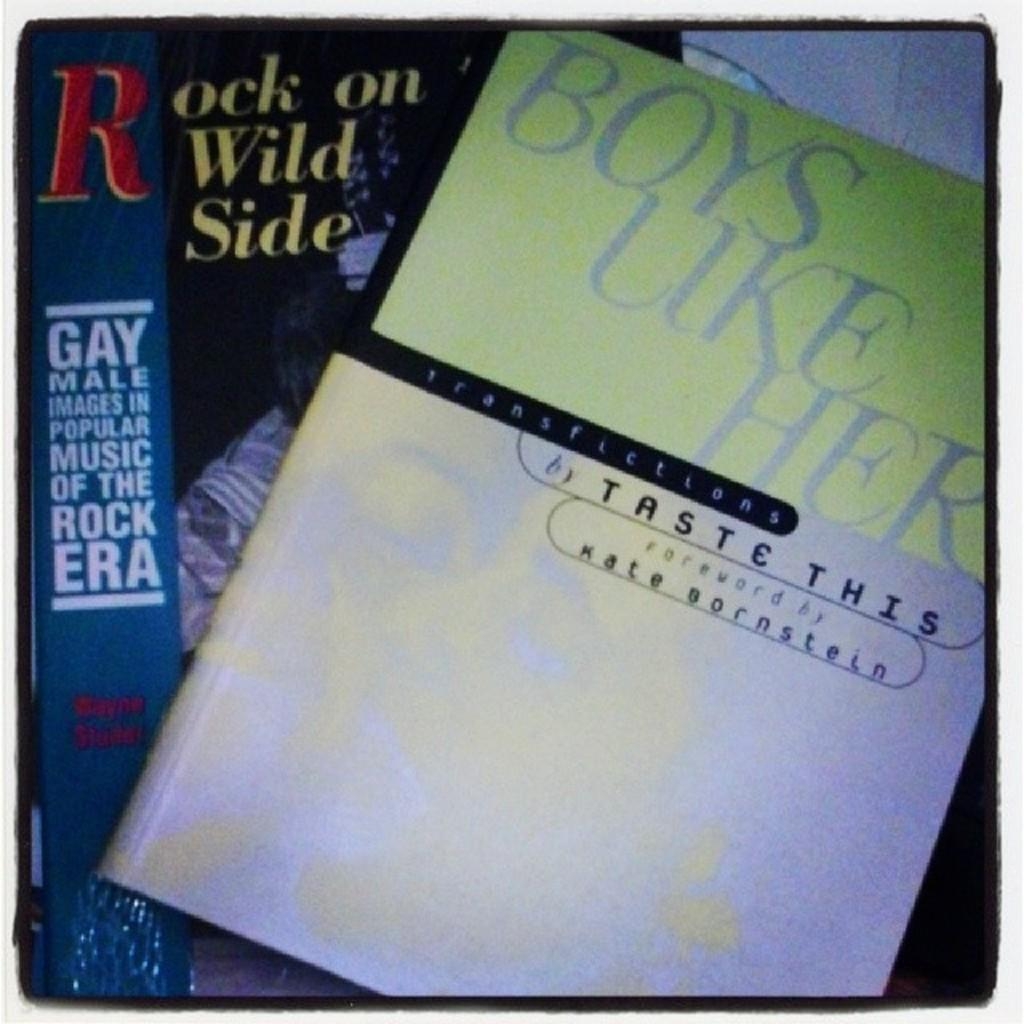Provide a one-sentence caption for the provided image. Rock on the Wild Side is a book about gay musicians. 